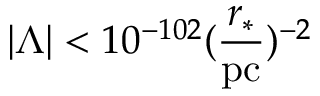<formula> <loc_0><loc_0><loc_500><loc_500>| \Lambda | < 1 0 ^ { - 1 0 2 } ( \frac { r _ { * } } { p c } ) ^ { - 2 }</formula> 